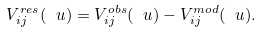Convert formula to latex. <formula><loc_0><loc_0><loc_500><loc_500>V _ { i j } ^ { r e s } ( \ u ) = V _ { i j } ^ { o b s } ( \ u ) - V _ { i j } ^ { m o d } ( \ u ) .</formula> 